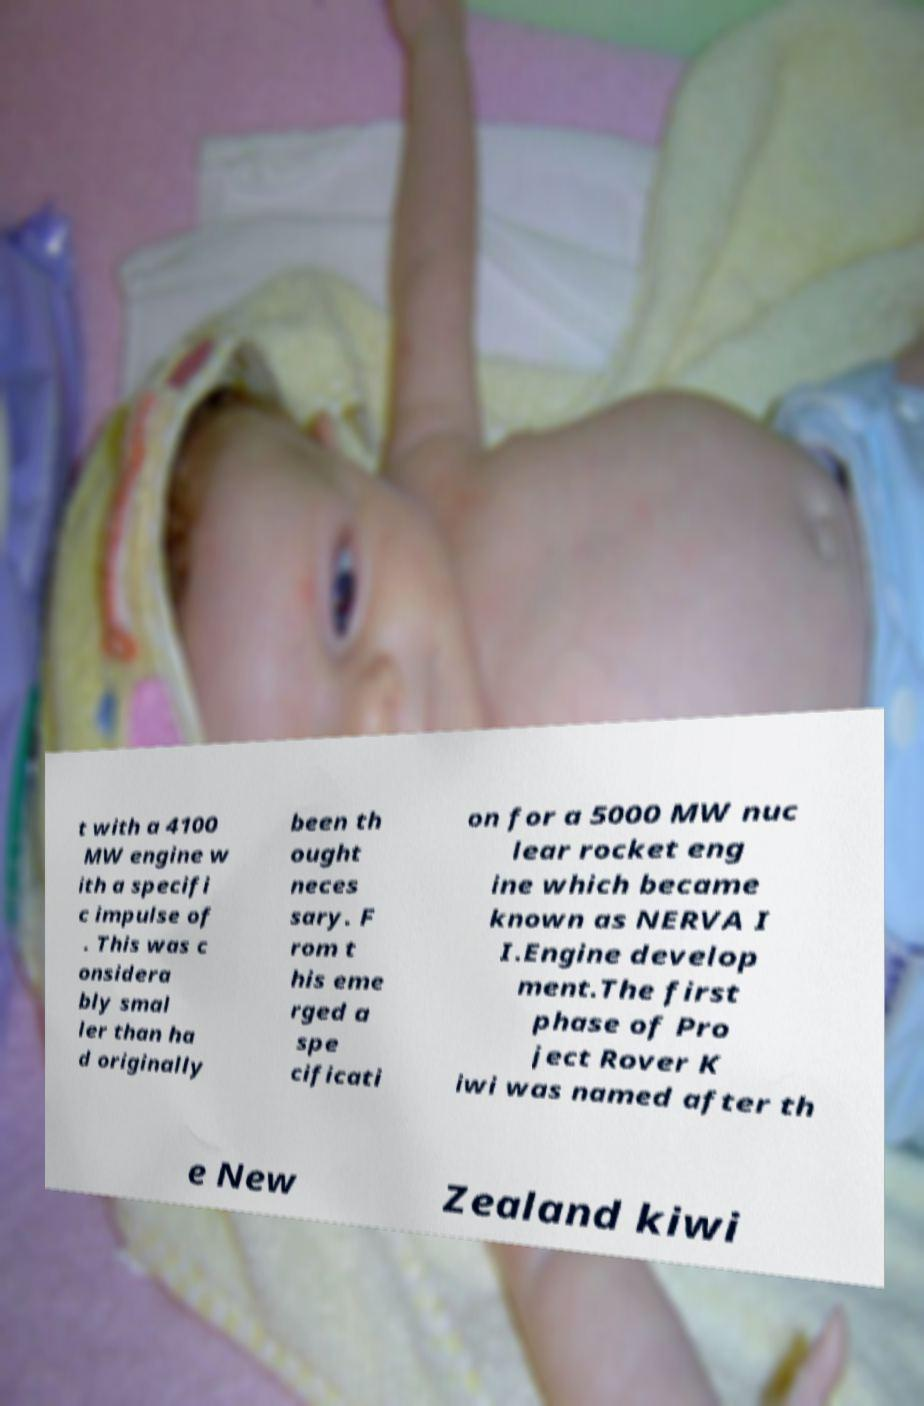Could you extract and type out the text from this image? t with a 4100 MW engine w ith a specifi c impulse of . This was c onsidera bly smal ler than ha d originally been th ought neces sary. F rom t his eme rged a spe cificati on for a 5000 MW nuc lear rocket eng ine which became known as NERVA I I.Engine develop ment.The first phase of Pro ject Rover K iwi was named after th e New Zealand kiwi 